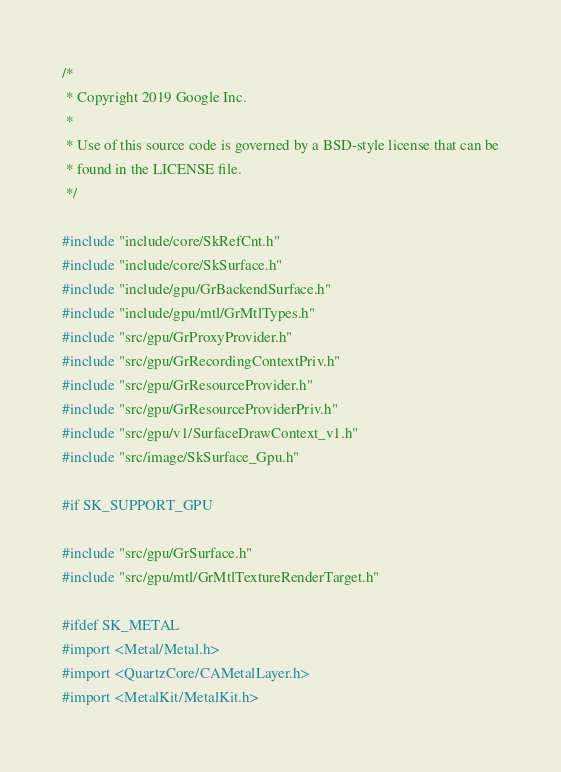Convert code to text. <code><loc_0><loc_0><loc_500><loc_500><_ObjectiveC_>/*
 * Copyright 2019 Google Inc.
 *
 * Use of this source code is governed by a BSD-style license that can be
 * found in the LICENSE file.
 */

#include "include/core/SkRefCnt.h"
#include "include/core/SkSurface.h"
#include "include/gpu/GrBackendSurface.h"
#include "include/gpu/mtl/GrMtlTypes.h"
#include "src/gpu/GrProxyProvider.h"
#include "src/gpu/GrRecordingContextPriv.h"
#include "src/gpu/GrResourceProvider.h"
#include "src/gpu/GrResourceProviderPriv.h"
#include "src/gpu/v1/SurfaceDrawContext_v1.h"
#include "src/image/SkSurface_Gpu.h"

#if SK_SUPPORT_GPU

#include "src/gpu/GrSurface.h"
#include "src/gpu/mtl/GrMtlTextureRenderTarget.h"

#ifdef SK_METAL
#import <Metal/Metal.h>
#import <QuartzCore/CAMetalLayer.h>
#import <MetalKit/MetalKit.h>
</code> 